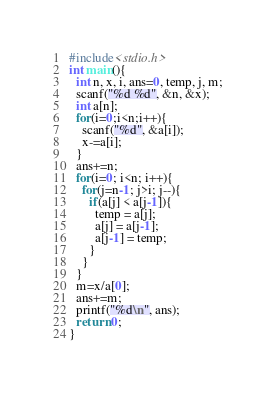Convert code to text. <code><loc_0><loc_0><loc_500><loc_500><_C_>#include<stdio.h>
int main(){
  int n, x, i, ans=0, temp, j, m;
  scanf("%d %d", &n, &x);
  int a[n];
  for(i=0;i<n;i++){
    scanf("%d", &a[i]);
    x-=a[i];
  }
  ans+=n;
  for(i=0; i<n; i++){
    for(j=n-1; j>i; j--){
      if(a[j] < a[j-1]){
        temp = a[j];
        a[j] = a[j-1];
        a[j-1] = temp;
      }
    }
  }
  m=x/a[0];
  ans+=m;
  printf("%d\n", ans);
  return 0;
}
</code> 